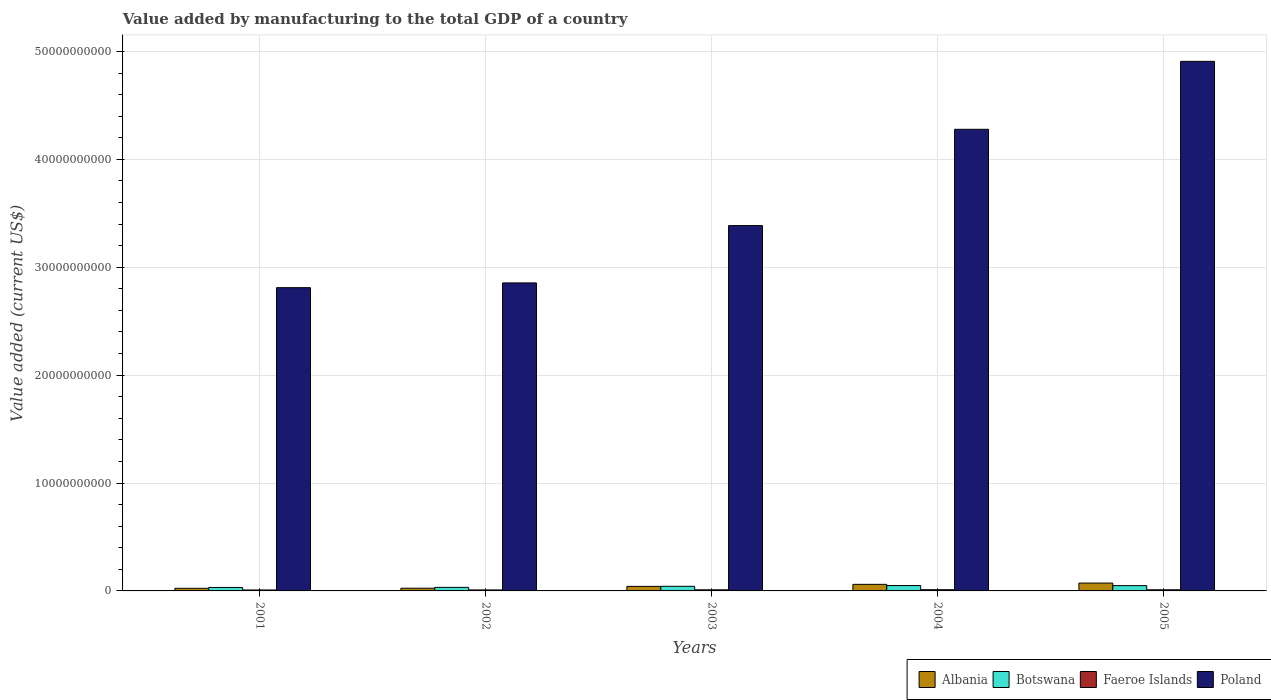How many different coloured bars are there?
Offer a very short reply. 4. How many groups of bars are there?
Your answer should be very brief. 5. Are the number of bars per tick equal to the number of legend labels?
Make the answer very short. Yes. What is the label of the 3rd group of bars from the left?
Give a very brief answer. 2003. What is the value added by manufacturing to the total GDP in Poland in 2001?
Make the answer very short. 2.81e+1. Across all years, what is the maximum value added by manufacturing to the total GDP in Botswana?
Ensure brevity in your answer.  4.98e+08. Across all years, what is the minimum value added by manufacturing to the total GDP in Botswana?
Ensure brevity in your answer.  3.21e+08. In which year was the value added by manufacturing to the total GDP in Albania minimum?
Your answer should be very brief. 2001. What is the total value added by manufacturing to the total GDP in Faeroe Islands in the graph?
Give a very brief answer. 5.01e+08. What is the difference between the value added by manufacturing to the total GDP in Botswana in 2001 and that in 2002?
Provide a succinct answer. -8.83e+06. What is the difference between the value added by manufacturing to the total GDP in Albania in 2001 and the value added by manufacturing to the total GDP in Poland in 2004?
Your answer should be compact. -4.25e+1. What is the average value added by manufacturing to the total GDP in Botswana per year?
Offer a terse response. 4.14e+08. In the year 2004, what is the difference between the value added by manufacturing to the total GDP in Albania and value added by manufacturing to the total GDP in Faeroe Islands?
Offer a terse response. 4.96e+08. What is the ratio of the value added by manufacturing to the total GDP in Botswana in 2002 to that in 2005?
Offer a very short reply. 0.67. Is the value added by manufacturing to the total GDP in Faeroe Islands in 2001 less than that in 2005?
Keep it short and to the point. Yes. Is the difference between the value added by manufacturing to the total GDP in Albania in 2001 and 2002 greater than the difference between the value added by manufacturing to the total GDP in Faeroe Islands in 2001 and 2002?
Provide a short and direct response. No. What is the difference between the highest and the second highest value added by manufacturing to the total GDP in Poland?
Ensure brevity in your answer.  6.30e+09. What is the difference between the highest and the lowest value added by manufacturing to the total GDP in Albania?
Provide a short and direct response. 4.86e+08. In how many years, is the value added by manufacturing to the total GDP in Botswana greater than the average value added by manufacturing to the total GDP in Botswana taken over all years?
Your answer should be very brief. 3. Is the sum of the value added by manufacturing to the total GDP in Faeroe Islands in 2002 and 2004 greater than the maximum value added by manufacturing to the total GDP in Albania across all years?
Your answer should be very brief. No. What does the 4th bar from the left in 2004 represents?
Provide a succinct answer. Poland. What does the 1st bar from the right in 2004 represents?
Your response must be concise. Poland. Are all the bars in the graph horizontal?
Offer a terse response. No. Are the values on the major ticks of Y-axis written in scientific E-notation?
Your response must be concise. No. How many legend labels are there?
Your answer should be very brief. 4. What is the title of the graph?
Ensure brevity in your answer.  Value added by manufacturing to the total GDP of a country. Does "Sub-Saharan Africa (all income levels)" appear as one of the legend labels in the graph?
Ensure brevity in your answer.  No. What is the label or title of the X-axis?
Make the answer very short. Years. What is the label or title of the Y-axis?
Provide a short and direct response. Value added (current US$). What is the Value added (current US$) in Albania in 2001?
Make the answer very short. 2.42e+08. What is the Value added (current US$) in Botswana in 2001?
Offer a very short reply. 3.21e+08. What is the Value added (current US$) in Faeroe Islands in 2001?
Offer a terse response. 8.87e+07. What is the Value added (current US$) of Poland in 2001?
Provide a succinct answer. 2.81e+1. What is the Value added (current US$) in Albania in 2002?
Give a very brief answer. 2.51e+08. What is the Value added (current US$) in Botswana in 2002?
Your answer should be very brief. 3.29e+08. What is the Value added (current US$) in Faeroe Islands in 2002?
Keep it short and to the point. 9.15e+07. What is the Value added (current US$) in Poland in 2002?
Keep it short and to the point. 2.85e+1. What is the Value added (current US$) in Albania in 2003?
Your answer should be compact. 4.21e+08. What is the Value added (current US$) of Botswana in 2003?
Provide a short and direct response. 4.29e+08. What is the Value added (current US$) of Faeroe Islands in 2003?
Your answer should be very brief. 1.04e+08. What is the Value added (current US$) in Poland in 2003?
Provide a short and direct response. 3.39e+1. What is the Value added (current US$) of Albania in 2004?
Your response must be concise. 6.09e+08. What is the Value added (current US$) of Botswana in 2004?
Provide a short and direct response. 4.98e+08. What is the Value added (current US$) in Faeroe Islands in 2004?
Ensure brevity in your answer.  1.12e+08. What is the Value added (current US$) of Poland in 2004?
Provide a succinct answer. 4.28e+1. What is the Value added (current US$) of Albania in 2005?
Your answer should be very brief. 7.28e+08. What is the Value added (current US$) in Botswana in 2005?
Your answer should be compact. 4.92e+08. What is the Value added (current US$) of Faeroe Islands in 2005?
Provide a short and direct response. 1.04e+08. What is the Value added (current US$) in Poland in 2005?
Your answer should be very brief. 4.91e+1. Across all years, what is the maximum Value added (current US$) in Albania?
Your response must be concise. 7.28e+08. Across all years, what is the maximum Value added (current US$) in Botswana?
Provide a succinct answer. 4.98e+08. Across all years, what is the maximum Value added (current US$) in Faeroe Islands?
Your answer should be compact. 1.12e+08. Across all years, what is the maximum Value added (current US$) of Poland?
Offer a terse response. 4.91e+1. Across all years, what is the minimum Value added (current US$) of Albania?
Offer a very short reply. 2.42e+08. Across all years, what is the minimum Value added (current US$) in Botswana?
Your response must be concise. 3.21e+08. Across all years, what is the minimum Value added (current US$) in Faeroe Islands?
Ensure brevity in your answer.  8.87e+07. Across all years, what is the minimum Value added (current US$) in Poland?
Your answer should be very brief. 2.81e+1. What is the total Value added (current US$) in Albania in the graph?
Give a very brief answer. 2.25e+09. What is the total Value added (current US$) in Botswana in the graph?
Your response must be concise. 2.07e+09. What is the total Value added (current US$) of Faeroe Islands in the graph?
Make the answer very short. 5.01e+08. What is the total Value added (current US$) of Poland in the graph?
Give a very brief answer. 1.82e+11. What is the difference between the Value added (current US$) in Albania in 2001 and that in 2002?
Keep it short and to the point. -9.36e+06. What is the difference between the Value added (current US$) in Botswana in 2001 and that in 2002?
Your answer should be very brief. -8.83e+06. What is the difference between the Value added (current US$) in Faeroe Islands in 2001 and that in 2002?
Make the answer very short. -2.78e+06. What is the difference between the Value added (current US$) in Poland in 2001 and that in 2002?
Provide a short and direct response. -4.39e+08. What is the difference between the Value added (current US$) in Albania in 2001 and that in 2003?
Offer a terse response. -1.79e+08. What is the difference between the Value added (current US$) of Botswana in 2001 and that in 2003?
Ensure brevity in your answer.  -1.08e+08. What is the difference between the Value added (current US$) of Faeroe Islands in 2001 and that in 2003?
Give a very brief answer. -1.55e+07. What is the difference between the Value added (current US$) of Poland in 2001 and that in 2003?
Offer a very short reply. -5.75e+09. What is the difference between the Value added (current US$) of Albania in 2001 and that in 2004?
Ensure brevity in your answer.  -3.67e+08. What is the difference between the Value added (current US$) in Botswana in 2001 and that in 2004?
Your answer should be compact. -1.77e+08. What is the difference between the Value added (current US$) of Faeroe Islands in 2001 and that in 2004?
Make the answer very short. -2.37e+07. What is the difference between the Value added (current US$) of Poland in 2001 and that in 2004?
Make the answer very short. -1.47e+1. What is the difference between the Value added (current US$) in Albania in 2001 and that in 2005?
Your answer should be compact. -4.86e+08. What is the difference between the Value added (current US$) of Botswana in 2001 and that in 2005?
Ensure brevity in your answer.  -1.71e+08. What is the difference between the Value added (current US$) of Faeroe Islands in 2001 and that in 2005?
Provide a succinct answer. -1.55e+07. What is the difference between the Value added (current US$) in Poland in 2001 and that in 2005?
Provide a short and direct response. -2.10e+1. What is the difference between the Value added (current US$) in Albania in 2002 and that in 2003?
Make the answer very short. -1.69e+08. What is the difference between the Value added (current US$) in Botswana in 2002 and that in 2003?
Provide a short and direct response. -9.91e+07. What is the difference between the Value added (current US$) of Faeroe Islands in 2002 and that in 2003?
Offer a terse response. -1.27e+07. What is the difference between the Value added (current US$) of Poland in 2002 and that in 2003?
Provide a short and direct response. -5.31e+09. What is the difference between the Value added (current US$) of Albania in 2002 and that in 2004?
Your response must be concise. -3.57e+08. What is the difference between the Value added (current US$) of Botswana in 2002 and that in 2004?
Make the answer very short. -1.68e+08. What is the difference between the Value added (current US$) in Faeroe Islands in 2002 and that in 2004?
Give a very brief answer. -2.09e+07. What is the difference between the Value added (current US$) of Poland in 2002 and that in 2004?
Your response must be concise. -1.42e+1. What is the difference between the Value added (current US$) in Albania in 2002 and that in 2005?
Keep it short and to the point. -4.77e+08. What is the difference between the Value added (current US$) of Botswana in 2002 and that in 2005?
Provide a succinct answer. -1.62e+08. What is the difference between the Value added (current US$) in Faeroe Islands in 2002 and that in 2005?
Offer a terse response. -1.28e+07. What is the difference between the Value added (current US$) in Poland in 2002 and that in 2005?
Provide a short and direct response. -2.05e+1. What is the difference between the Value added (current US$) in Albania in 2003 and that in 2004?
Offer a terse response. -1.88e+08. What is the difference between the Value added (current US$) in Botswana in 2003 and that in 2004?
Your response must be concise. -6.89e+07. What is the difference between the Value added (current US$) in Faeroe Islands in 2003 and that in 2004?
Provide a short and direct response. -8.20e+06. What is the difference between the Value added (current US$) of Poland in 2003 and that in 2004?
Provide a short and direct response. -8.92e+09. What is the difference between the Value added (current US$) in Albania in 2003 and that in 2005?
Ensure brevity in your answer.  -3.07e+08. What is the difference between the Value added (current US$) of Botswana in 2003 and that in 2005?
Ensure brevity in your answer.  -6.30e+07. What is the difference between the Value added (current US$) of Faeroe Islands in 2003 and that in 2005?
Keep it short and to the point. -8.69e+04. What is the difference between the Value added (current US$) of Poland in 2003 and that in 2005?
Provide a short and direct response. -1.52e+1. What is the difference between the Value added (current US$) in Albania in 2004 and that in 2005?
Keep it short and to the point. -1.20e+08. What is the difference between the Value added (current US$) in Botswana in 2004 and that in 2005?
Provide a succinct answer. 5.97e+06. What is the difference between the Value added (current US$) of Faeroe Islands in 2004 and that in 2005?
Your answer should be compact. 8.11e+06. What is the difference between the Value added (current US$) of Poland in 2004 and that in 2005?
Provide a succinct answer. -6.30e+09. What is the difference between the Value added (current US$) of Albania in 2001 and the Value added (current US$) of Botswana in 2002?
Give a very brief answer. -8.73e+07. What is the difference between the Value added (current US$) in Albania in 2001 and the Value added (current US$) in Faeroe Islands in 2002?
Your answer should be very brief. 1.51e+08. What is the difference between the Value added (current US$) in Albania in 2001 and the Value added (current US$) in Poland in 2002?
Your answer should be compact. -2.83e+1. What is the difference between the Value added (current US$) in Botswana in 2001 and the Value added (current US$) in Faeroe Islands in 2002?
Give a very brief answer. 2.29e+08. What is the difference between the Value added (current US$) of Botswana in 2001 and the Value added (current US$) of Poland in 2002?
Make the answer very short. -2.82e+1. What is the difference between the Value added (current US$) in Faeroe Islands in 2001 and the Value added (current US$) in Poland in 2002?
Give a very brief answer. -2.85e+1. What is the difference between the Value added (current US$) in Albania in 2001 and the Value added (current US$) in Botswana in 2003?
Offer a terse response. -1.86e+08. What is the difference between the Value added (current US$) of Albania in 2001 and the Value added (current US$) of Faeroe Islands in 2003?
Offer a very short reply. 1.38e+08. What is the difference between the Value added (current US$) of Albania in 2001 and the Value added (current US$) of Poland in 2003?
Provide a succinct answer. -3.36e+1. What is the difference between the Value added (current US$) of Botswana in 2001 and the Value added (current US$) of Faeroe Islands in 2003?
Your answer should be compact. 2.16e+08. What is the difference between the Value added (current US$) of Botswana in 2001 and the Value added (current US$) of Poland in 2003?
Provide a succinct answer. -3.35e+1. What is the difference between the Value added (current US$) of Faeroe Islands in 2001 and the Value added (current US$) of Poland in 2003?
Keep it short and to the point. -3.38e+1. What is the difference between the Value added (current US$) in Albania in 2001 and the Value added (current US$) in Botswana in 2004?
Give a very brief answer. -2.55e+08. What is the difference between the Value added (current US$) of Albania in 2001 and the Value added (current US$) of Faeroe Islands in 2004?
Provide a succinct answer. 1.30e+08. What is the difference between the Value added (current US$) in Albania in 2001 and the Value added (current US$) in Poland in 2004?
Your answer should be compact. -4.25e+1. What is the difference between the Value added (current US$) in Botswana in 2001 and the Value added (current US$) in Faeroe Islands in 2004?
Offer a terse response. 2.08e+08. What is the difference between the Value added (current US$) in Botswana in 2001 and the Value added (current US$) in Poland in 2004?
Offer a very short reply. -4.25e+1. What is the difference between the Value added (current US$) in Faeroe Islands in 2001 and the Value added (current US$) in Poland in 2004?
Offer a terse response. -4.27e+1. What is the difference between the Value added (current US$) in Albania in 2001 and the Value added (current US$) in Botswana in 2005?
Offer a very short reply. -2.49e+08. What is the difference between the Value added (current US$) of Albania in 2001 and the Value added (current US$) of Faeroe Islands in 2005?
Give a very brief answer. 1.38e+08. What is the difference between the Value added (current US$) in Albania in 2001 and the Value added (current US$) in Poland in 2005?
Offer a very short reply. -4.88e+1. What is the difference between the Value added (current US$) in Botswana in 2001 and the Value added (current US$) in Faeroe Islands in 2005?
Make the answer very short. 2.16e+08. What is the difference between the Value added (current US$) of Botswana in 2001 and the Value added (current US$) of Poland in 2005?
Provide a succinct answer. -4.88e+1. What is the difference between the Value added (current US$) in Faeroe Islands in 2001 and the Value added (current US$) in Poland in 2005?
Provide a short and direct response. -4.90e+1. What is the difference between the Value added (current US$) of Albania in 2002 and the Value added (current US$) of Botswana in 2003?
Give a very brief answer. -1.77e+08. What is the difference between the Value added (current US$) in Albania in 2002 and the Value added (current US$) in Faeroe Islands in 2003?
Your answer should be compact. 1.47e+08. What is the difference between the Value added (current US$) in Albania in 2002 and the Value added (current US$) in Poland in 2003?
Ensure brevity in your answer.  -3.36e+1. What is the difference between the Value added (current US$) in Botswana in 2002 and the Value added (current US$) in Faeroe Islands in 2003?
Your response must be concise. 2.25e+08. What is the difference between the Value added (current US$) of Botswana in 2002 and the Value added (current US$) of Poland in 2003?
Your answer should be very brief. -3.35e+1. What is the difference between the Value added (current US$) in Faeroe Islands in 2002 and the Value added (current US$) in Poland in 2003?
Keep it short and to the point. -3.38e+1. What is the difference between the Value added (current US$) of Albania in 2002 and the Value added (current US$) of Botswana in 2004?
Your answer should be very brief. -2.46e+08. What is the difference between the Value added (current US$) in Albania in 2002 and the Value added (current US$) in Faeroe Islands in 2004?
Make the answer very short. 1.39e+08. What is the difference between the Value added (current US$) in Albania in 2002 and the Value added (current US$) in Poland in 2004?
Provide a short and direct response. -4.25e+1. What is the difference between the Value added (current US$) of Botswana in 2002 and the Value added (current US$) of Faeroe Islands in 2004?
Keep it short and to the point. 2.17e+08. What is the difference between the Value added (current US$) of Botswana in 2002 and the Value added (current US$) of Poland in 2004?
Your answer should be compact. -4.25e+1. What is the difference between the Value added (current US$) of Faeroe Islands in 2002 and the Value added (current US$) of Poland in 2004?
Provide a succinct answer. -4.27e+1. What is the difference between the Value added (current US$) in Albania in 2002 and the Value added (current US$) in Botswana in 2005?
Make the answer very short. -2.40e+08. What is the difference between the Value added (current US$) of Albania in 2002 and the Value added (current US$) of Faeroe Islands in 2005?
Make the answer very short. 1.47e+08. What is the difference between the Value added (current US$) of Albania in 2002 and the Value added (current US$) of Poland in 2005?
Your answer should be very brief. -4.88e+1. What is the difference between the Value added (current US$) in Botswana in 2002 and the Value added (current US$) in Faeroe Islands in 2005?
Provide a succinct answer. 2.25e+08. What is the difference between the Value added (current US$) of Botswana in 2002 and the Value added (current US$) of Poland in 2005?
Provide a short and direct response. -4.88e+1. What is the difference between the Value added (current US$) of Faeroe Islands in 2002 and the Value added (current US$) of Poland in 2005?
Your response must be concise. -4.90e+1. What is the difference between the Value added (current US$) of Albania in 2003 and the Value added (current US$) of Botswana in 2004?
Your answer should be compact. -7.65e+07. What is the difference between the Value added (current US$) of Albania in 2003 and the Value added (current US$) of Faeroe Islands in 2004?
Ensure brevity in your answer.  3.09e+08. What is the difference between the Value added (current US$) in Albania in 2003 and the Value added (current US$) in Poland in 2004?
Keep it short and to the point. -4.24e+1. What is the difference between the Value added (current US$) in Botswana in 2003 and the Value added (current US$) in Faeroe Islands in 2004?
Keep it short and to the point. 3.16e+08. What is the difference between the Value added (current US$) of Botswana in 2003 and the Value added (current US$) of Poland in 2004?
Make the answer very short. -4.24e+1. What is the difference between the Value added (current US$) in Faeroe Islands in 2003 and the Value added (current US$) in Poland in 2004?
Your answer should be compact. -4.27e+1. What is the difference between the Value added (current US$) of Albania in 2003 and the Value added (current US$) of Botswana in 2005?
Provide a short and direct response. -7.06e+07. What is the difference between the Value added (current US$) of Albania in 2003 and the Value added (current US$) of Faeroe Islands in 2005?
Give a very brief answer. 3.17e+08. What is the difference between the Value added (current US$) of Albania in 2003 and the Value added (current US$) of Poland in 2005?
Provide a short and direct response. -4.87e+1. What is the difference between the Value added (current US$) of Botswana in 2003 and the Value added (current US$) of Faeroe Islands in 2005?
Keep it short and to the point. 3.24e+08. What is the difference between the Value added (current US$) of Botswana in 2003 and the Value added (current US$) of Poland in 2005?
Your answer should be compact. -4.87e+1. What is the difference between the Value added (current US$) of Faeroe Islands in 2003 and the Value added (current US$) of Poland in 2005?
Your answer should be compact. -4.90e+1. What is the difference between the Value added (current US$) in Albania in 2004 and the Value added (current US$) in Botswana in 2005?
Provide a short and direct response. 1.17e+08. What is the difference between the Value added (current US$) of Albania in 2004 and the Value added (current US$) of Faeroe Islands in 2005?
Give a very brief answer. 5.05e+08. What is the difference between the Value added (current US$) in Albania in 2004 and the Value added (current US$) in Poland in 2005?
Offer a very short reply. -4.85e+1. What is the difference between the Value added (current US$) of Botswana in 2004 and the Value added (current US$) of Faeroe Islands in 2005?
Ensure brevity in your answer.  3.93e+08. What is the difference between the Value added (current US$) in Botswana in 2004 and the Value added (current US$) in Poland in 2005?
Provide a succinct answer. -4.86e+1. What is the difference between the Value added (current US$) of Faeroe Islands in 2004 and the Value added (current US$) of Poland in 2005?
Keep it short and to the point. -4.90e+1. What is the average Value added (current US$) of Albania per year?
Offer a terse response. 4.50e+08. What is the average Value added (current US$) of Botswana per year?
Your answer should be very brief. 4.14e+08. What is the average Value added (current US$) of Faeroe Islands per year?
Your answer should be compact. 1.00e+08. What is the average Value added (current US$) of Poland per year?
Your response must be concise. 3.65e+1. In the year 2001, what is the difference between the Value added (current US$) of Albania and Value added (current US$) of Botswana?
Offer a terse response. -7.85e+07. In the year 2001, what is the difference between the Value added (current US$) of Albania and Value added (current US$) of Faeroe Islands?
Give a very brief answer. 1.53e+08. In the year 2001, what is the difference between the Value added (current US$) of Albania and Value added (current US$) of Poland?
Offer a terse response. -2.79e+1. In the year 2001, what is the difference between the Value added (current US$) in Botswana and Value added (current US$) in Faeroe Islands?
Provide a short and direct response. 2.32e+08. In the year 2001, what is the difference between the Value added (current US$) of Botswana and Value added (current US$) of Poland?
Your answer should be very brief. -2.78e+1. In the year 2001, what is the difference between the Value added (current US$) in Faeroe Islands and Value added (current US$) in Poland?
Give a very brief answer. -2.80e+1. In the year 2002, what is the difference between the Value added (current US$) of Albania and Value added (current US$) of Botswana?
Your response must be concise. -7.79e+07. In the year 2002, what is the difference between the Value added (current US$) of Albania and Value added (current US$) of Faeroe Islands?
Offer a very short reply. 1.60e+08. In the year 2002, what is the difference between the Value added (current US$) of Albania and Value added (current US$) of Poland?
Offer a very short reply. -2.83e+1. In the year 2002, what is the difference between the Value added (current US$) of Botswana and Value added (current US$) of Faeroe Islands?
Your answer should be very brief. 2.38e+08. In the year 2002, what is the difference between the Value added (current US$) of Botswana and Value added (current US$) of Poland?
Ensure brevity in your answer.  -2.82e+1. In the year 2002, what is the difference between the Value added (current US$) in Faeroe Islands and Value added (current US$) in Poland?
Provide a short and direct response. -2.85e+1. In the year 2003, what is the difference between the Value added (current US$) of Albania and Value added (current US$) of Botswana?
Make the answer very short. -7.60e+06. In the year 2003, what is the difference between the Value added (current US$) in Albania and Value added (current US$) in Faeroe Islands?
Provide a short and direct response. 3.17e+08. In the year 2003, what is the difference between the Value added (current US$) in Albania and Value added (current US$) in Poland?
Make the answer very short. -3.34e+1. In the year 2003, what is the difference between the Value added (current US$) in Botswana and Value added (current US$) in Faeroe Islands?
Give a very brief answer. 3.24e+08. In the year 2003, what is the difference between the Value added (current US$) of Botswana and Value added (current US$) of Poland?
Provide a short and direct response. -3.34e+1. In the year 2003, what is the difference between the Value added (current US$) in Faeroe Islands and Value added (current US$) in Poland?
Provide a short and direct response. -3.38e+1. In the year 2004, what is the difference between the Value added (current US$) of Albania and Value added (current US$) of Botswana?
Your answer should be very brief. 1.11e+08. In the year 2004, what is the difference between the Value added (current US$) in Albania and Value added (current US$) in Faeroe Islands?
Give a very brief answer. 4.96e+08. In the year 2004, what is the difference between the Value added (current US$) in Albania and Value added (current US$) in Poland?
Your answer should be very brief. -4.22e+1. In the year 2004, what is the difference between the Value added (current US$) in Botswana and Value added (current US$) in Faeroe Islands?
Offer a very short reply. 3.85e+08. In the year 2004, what is the difference between the Value added (current US$) of Botswana and Value added (current US$) of Poland?
Your response must be concise. -4.23e+1. In the year 2004, what is the difference between the Value added (current US$) of Faeroe Islands and Value added (current US$) of Poland?
Keep it short and to the point. -4.27e+1. In the year 2005, what is the difference between the Value added (current US$) of Albania and Value added (current US$) of Botswana?
Give a very brief answer. 2.37e+08. In the year 2005, what is the difference between the Value added (current US$) of Albania and Value added (current US$) of Faeroe Islands?
Give a very brief answer. 6.24e+08. In the year 2005, what is the difference between the Value added (current US$) of Albania and Value added (current US$) of Poland?
Your answer should be very brief. -4.84e+1. In the year 2005, what is the difference between the Value added (current US$) in Botswana and Value added (current US$) in Faeroe Islands?
Your response must be concise. 3.87e+08. In the year 2005, what is the difference between the Value added (current US$) in Botswana and Value added (current US$) in Poland?
Your answer should be very brief. -4.86e+1. In the year 2005, what is the difference between the Value added (current US$) in Faeroe Islands and Value added (current US$) in Poland?
Provide a succinct answer. -4.90e+1. What is the ratio of the Value added (current US$) in Albania in 2001 to that in 2002?
Your answer should be very brief. 0.96. What is the ratio of the Value added (current US$) in Botswana in 2001 to that in 2002?
Provide a succinct answer. 0.97. What is the ratio of the Value added (current US$) in Faeroe Islands in 2001 to that in 2002?
Offer a very short reply. 0.97. What is the ratio of the Value added (current US$) of Poland in 2001 to that in 2002?
Your response must be concise. 0.98. What is the ratio of the Value added (current US$) in Albania in 2001 to that in 2003?
Your answer should be very brief. 0.58. What is the ratio of the Value added (current US$) of Botswana in 2001 to that in 2003?
Make the answer very short. 0.75. What is the ratio of the Value added (current US$) of Faeroe Islands in 2001 to that in 2003?
Provide a succinct answer. 0.85. What is the ratio of the Value added (current US$) in Poland in 2001 to that in 2003?
Offer a terse response. 0.83. What is the ratio of the Value added (current US$) of Albania in 2001 to that in 2004?
Make the answer very short. 0.4. What is the ratio of the Value added (current US$) in Botswana in 2001 to that in 2004?
Make the answer very short. 0.64. What is the ratio of the Value added (current US$) in Faeroe Islands in 2001 to that in 2004?
Provide a succinct answer. 0.79. What is the ratio of the Value added (current US$) in Poland in 2001 to that in 2004?
Give a very brief answer. 0.66. What is the ratio of the Value added (current US$) in Albania in 2001 to that in 2005?
Your answer should be compact. 0.33. What is the ratio of the Value added (current US$) of Botswana in 2001 to that in 2005?
Make the answer very short. 0.65. What is the ratio of the Value added (current US$) in Faeroe Islands in 2001 to that in 2005?
Make the answer very short. 0.85. What is the ratio of the Value added (current US$) in Poland in 2001 to that in 2005?
Ensure brevity in your answer.  0.57. What is the ratio of the Value added (current US$) of Albania in 2002 to that in 2003?
Ensure brevity in your answer.  0.6. What is the ratio of the Value added (current US$) in Botswana in 2002 to that in 2003?
Offer a terse response. 0.77. What is the ratio of the Value added (current US$) of Faeroe Islands in 2002 to that in 2003?
Keep it short and to the point. 0.88. What is the ratio of the Value added (current US$) in Poland in 2002 to that in 2003?
Your answer should be compact. 0.84. What is the ratio of the Value added (current US$) in Albania in 2002 to that in 2004?
Ensure brevity in your answer.  0.41. What is the ratio of the Value added (current US$) in Botswana in 2002 to that in 2004?
Your answer should be compact. 0.66. What is the ratio of the Value added (current US$) in Faeroe Islands in 2002 to that in 2004?
Ensure brevity in your answer.  0.81. What is the ratio of the Value added (current US$) of Poland in 2002 to that in 2004?
Ensure brevity in your answer.  0.67. What is the ratio of the Value added (current US$) in Albania in 2002 to that in 2005?
Give a very brief answer. 0.35. What is the ratio of the Value added (current US$) of Botswana in 2002 to that in 2005?
Provide a succinct answer. 0.67. What is the ratio of the Value added (current US$) in Faeroe Islands in 2002 to that in 2005?
Your answer should be compact. 0.88. What is the ratio of the Value added (current US$) in Poland in 2002 to that in 2005?
Keep it short and to the point. 0.58. What is the ratio of the Value added (current US$) of Albania in 2003 to that in 2004?
Provide a succinct answer. 0.69. What is the ratio of the Value added (current US$) in Botswana in 2003 to that in 2004?
Ensure brevity in your answer.  0.86. What is the ratio of the Value added (current US$) of Faeroe Islands in 2003 to that in 2004?
Offer a terse response. 0.93. What is the ratio of the Value added (current US$) of Poland in 2003 to that in 2004?
Provide a succinct answer. 0.79. What is the ratio of the Value added (current US$) in Albania in 2003 to that in 2005?
Offer a terse response. 0.58. What is the ratio of the Value added (current US$) in Botswana in 2003 to that in 2005?
Your answer should be very brief. 0.87. What is the ratio of the Value added (current US$) in Faeroe Islands in 2003 to that in 2005?
Ensure brevity in your answer.  1. What is the ratio of the Value added (current US$) in Poland in 2003 to that in 2005?
Offer a very short reply. 0.69. What is the ratio of the Value added (current US$) of Albania in 2004 to that in 2005?
Provide a short and direct response. 0.84. What is the ratio of the Value added (current US$) of Botswana in 2004 to that in 2005?
Offer a terse response. 1.01. What is the ratio of the Value added (current US$) of Faeroe Islands in 2004 to that in 2005?
Ensure brevity in your answer.  1.08. What is the ratio of the Value added (current US$) in Poland in 2004 to that in 2005?
Offer a very short reply. 0.87. What is the difference between the highest and the second highest Value added (current US$) in Albania?
Offer a very short reply. 1.20e+08. What is the difference between the highest and the second highest Value added (current US$) of Botswana?
Provide a succinct answer. 5.97e+06. What is the difference between the highest and the second highest Value added (current US$) in Faeroe Islands?
Your response must be concise. 8.11e+06. What is the difference between the highest and the second highest Value added (current US$) in Poland?
Your response must be concise. 6.30e+09. What is the difference between the highest and the lowest Value added (current US$) in Albania?
Provide a succinct answer. 4.86e+08. What is the difference between the highest and the lowest Value added (current US$) in Botswana?
Give a very brief answer. 1.77e+08. What is the difference between the highest and the lowest Value added (current US$) in Faeroe Islands?
Offer a very short reply. 2.37e+07. What is the difference between the highest and the lowest Value added (current US$) in Poland?
Provide a succinct answer. 2.10e+1. 